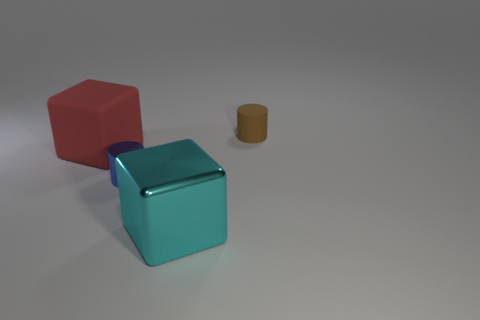There is a brown cylinder that is on the right side of the red block; is it the same size as the cylinder that is to the left of the tiny brown object? The brown cylinder on the right side of the red block is noticeably smaller in height compared to the cylinder on the left of the tiny brown object. Based on the perspective given in the image, the left cylinder appears taller, suggesting they are not the same size. 